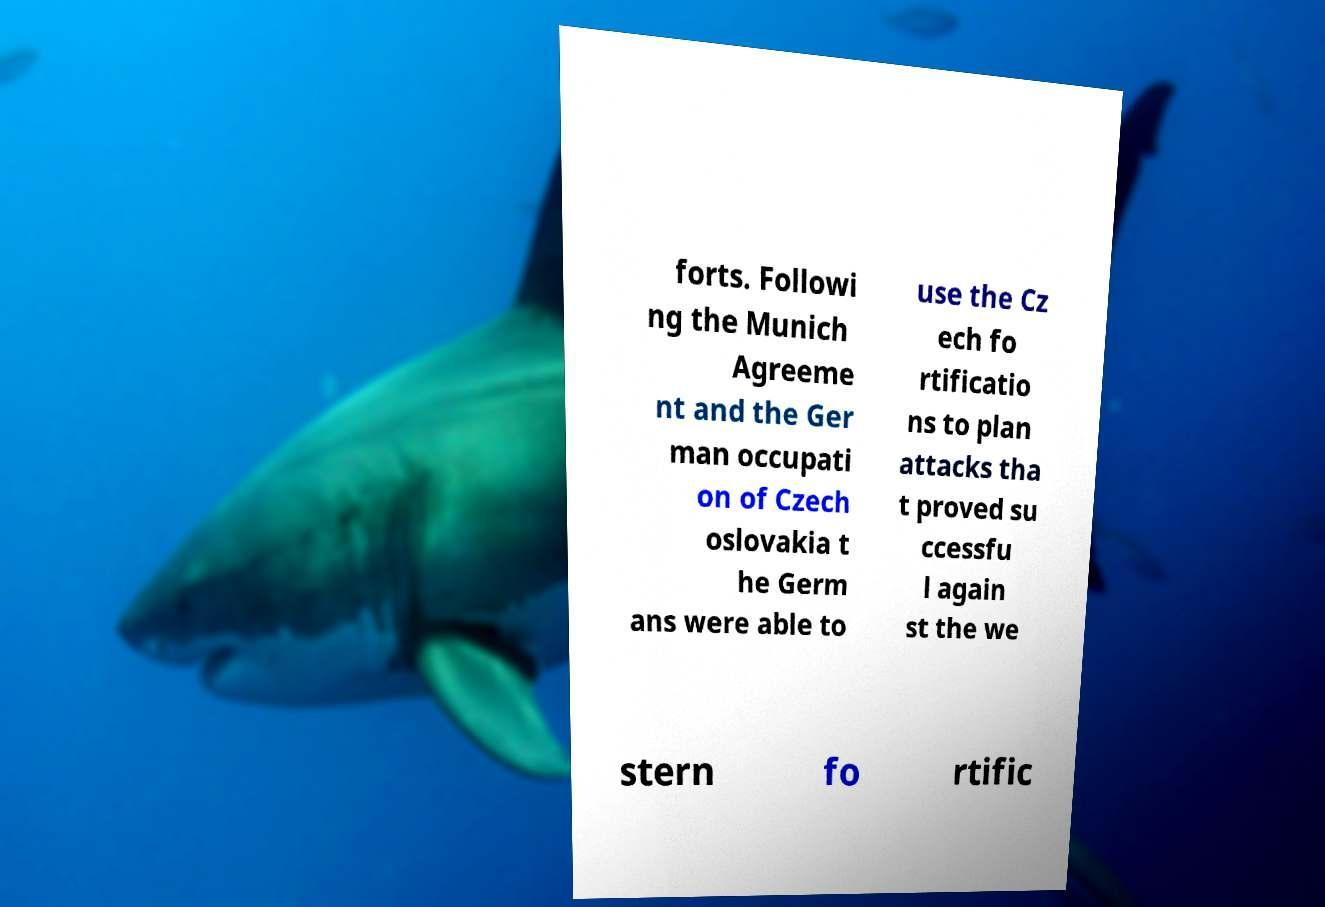Can you read and provide the text displayed in the image?This photo seems to have some interesting text. Can you extract and type it out for me? forts. Followi ng the Munich Agreeme nt and the Ger man occupati on of Czech oslovakia t he Germ ans were able to use the Cz ech fo rtificatio ns to plan attacks tha t proved su ccessfu l again st the we stern fo rtific 